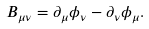<formula> <loc_0><loc_0><loc_500><loc_500>B _ { \mu \nu } = \partial _ { \mu } \phi _ { \nu } - \partial _ { \nu } \phi _ { \mu } .</formula> 